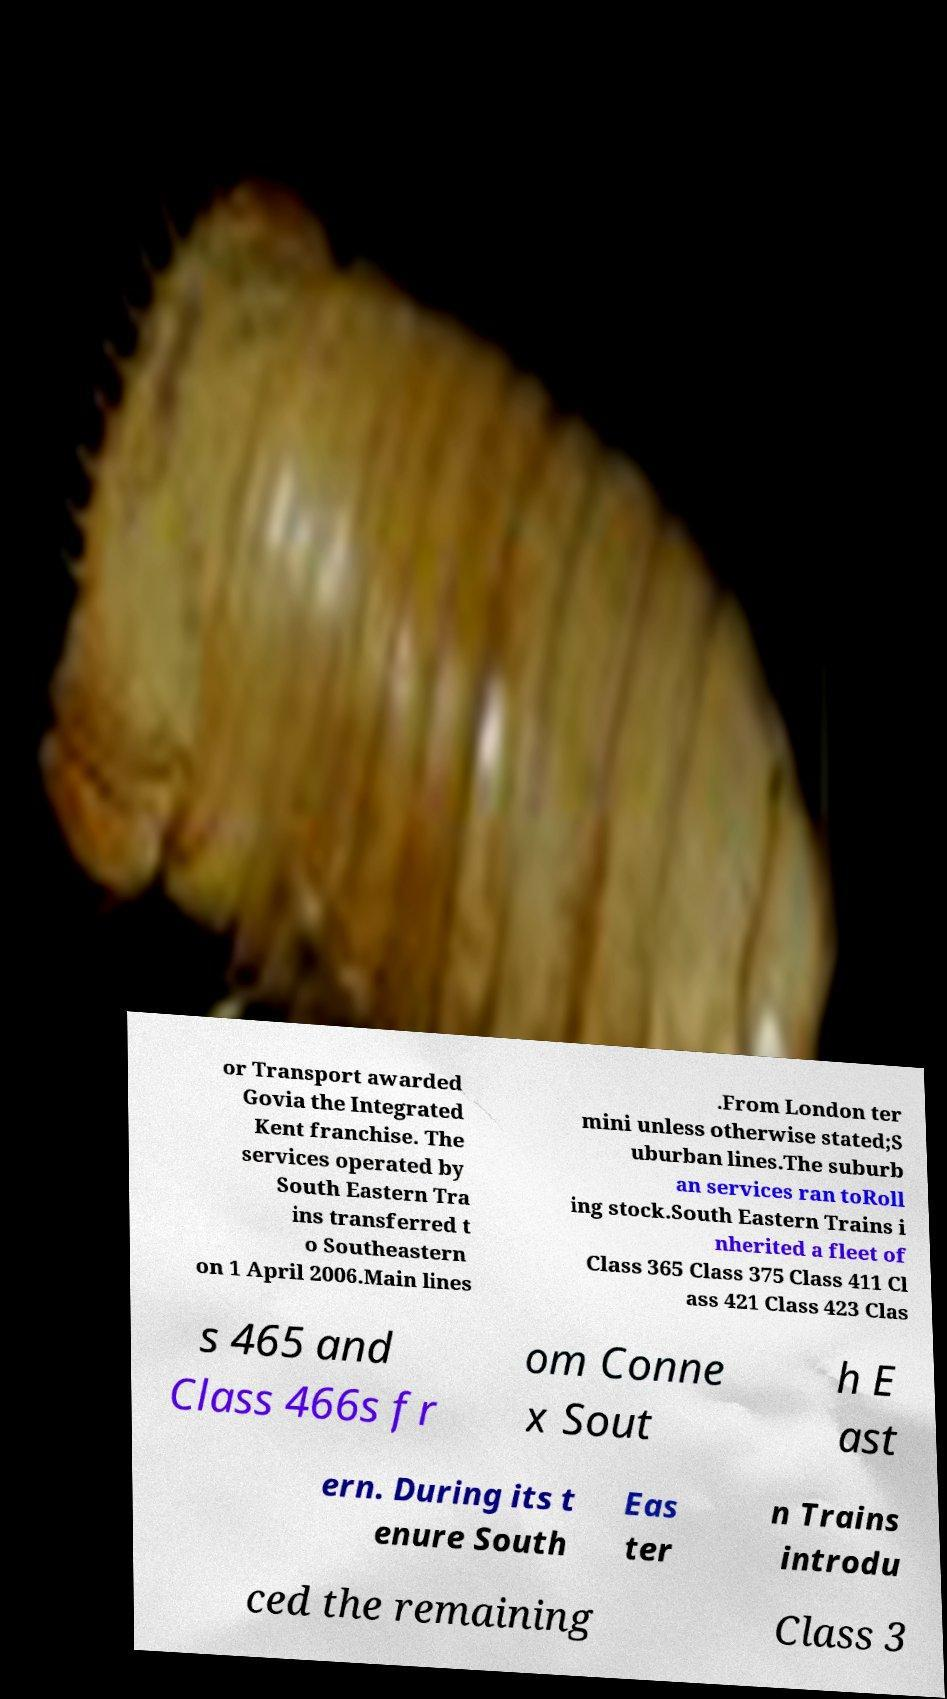I need the written content from this picture converted into text. Can you do that? or Transport awarded Govia the Integrated Kent franchise. The services operated by South Eastern Tra ins transferred t o Southeastern on 1 April 2006.Main lines .From London ter mini unless otherwise stated;S uburban lines.The suburb an services ran toRoll ing stock.South Eastern Trains i nherited a fleet of Class 365 Class 375 Class 411 Cl ass 421 Class 423 Clas s 465 and Class 466s fr om Conne x Sout h E ast ern. During its t enure South Eas ter n Trains introdu ced the remaining Class 3 